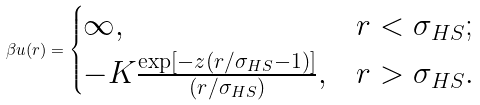<formula> <loc_0><loc_0><loc_500><loc_500>\beta u ( r ) = \begin{cases} \infty , & r < \sigma _ { H S } ; \\ - K \frac { \exp [ - z ( r / \sigma _ { H S } - 1 ) ] } { ( r / \sigma _ { H S } ) } , & r > \sigma _ { H S } . \end{cases}</formula> 